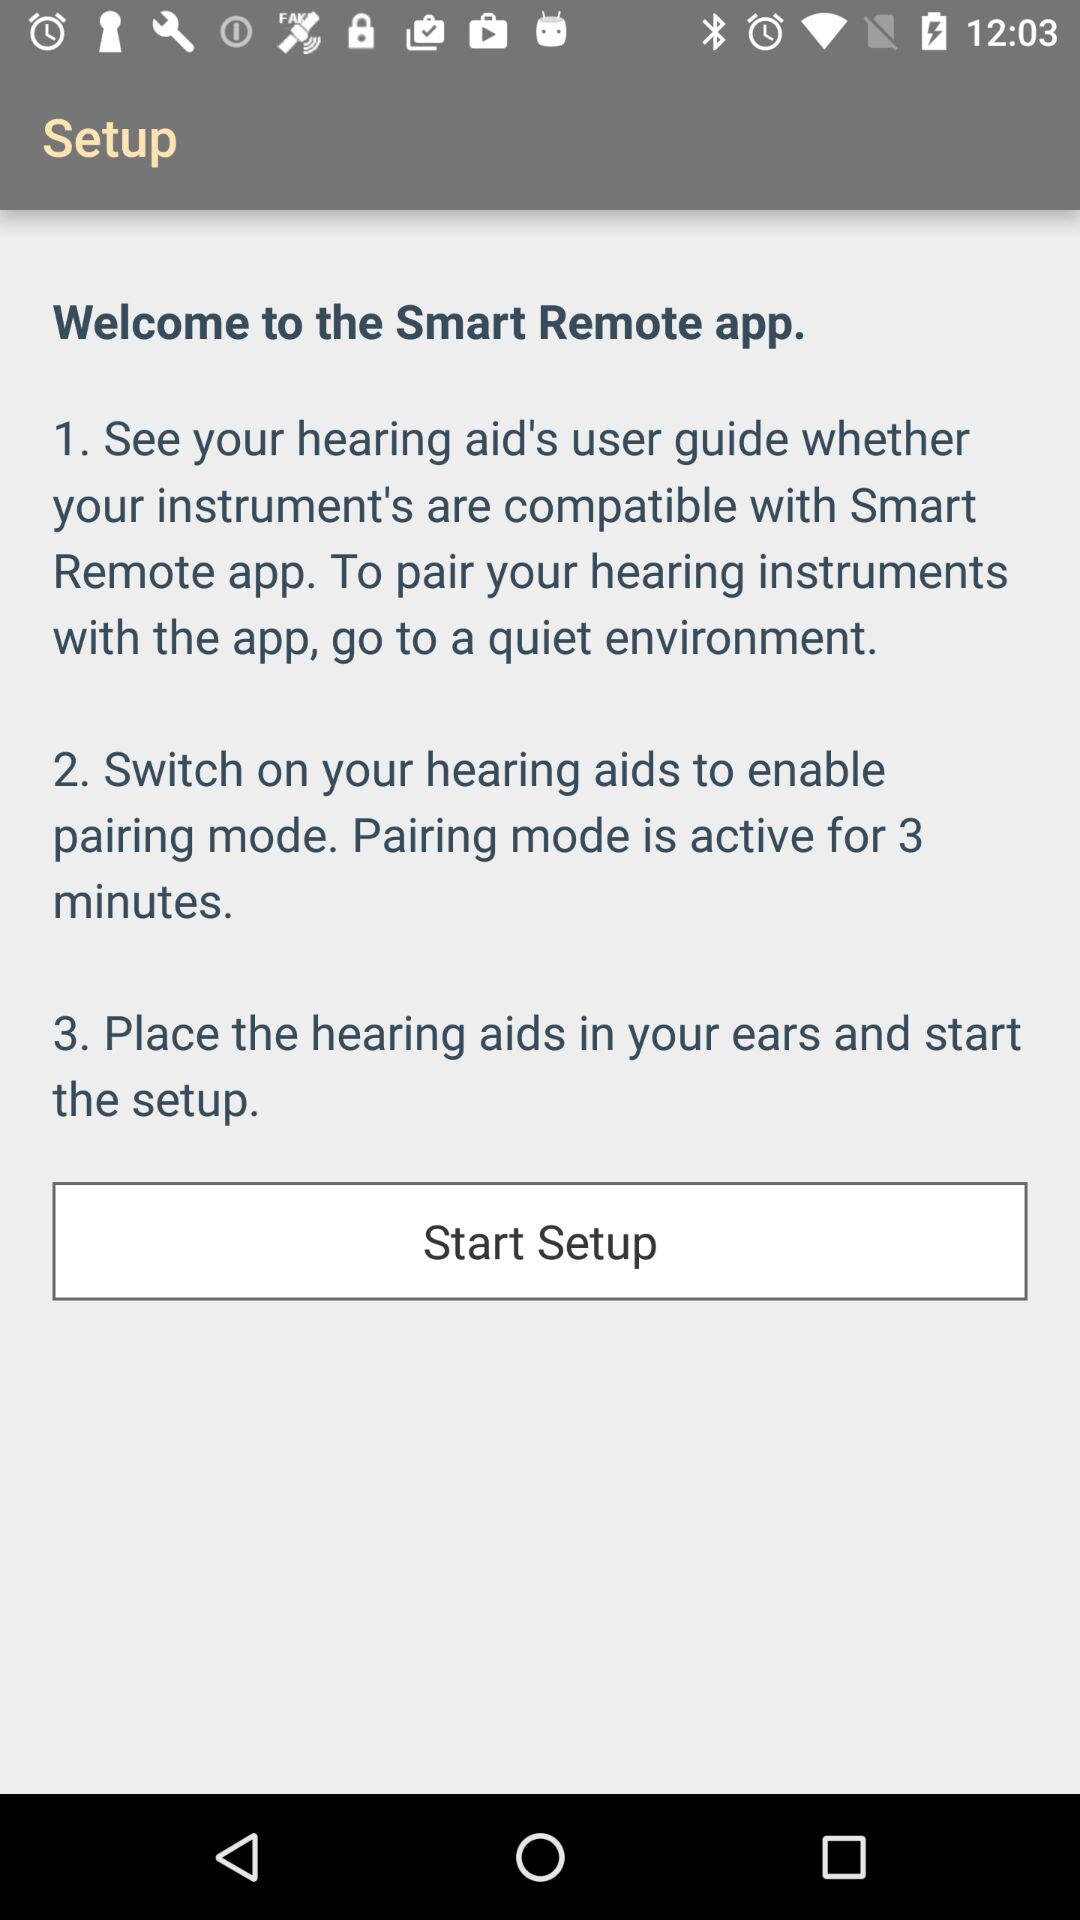How can we pair hearing instruments with the "Smart Remote" application? How can we pair hearing instruments with the "Smart Remote" application? The steps to pair hearing instruments are "To pair your hearing instruments with the app, go to a quiet environment", "Switch on your hearing aids to enable pairing mode. Pairing mode is active for 3 minutes" and "Place the hearing aids in your ears and start the setup". 